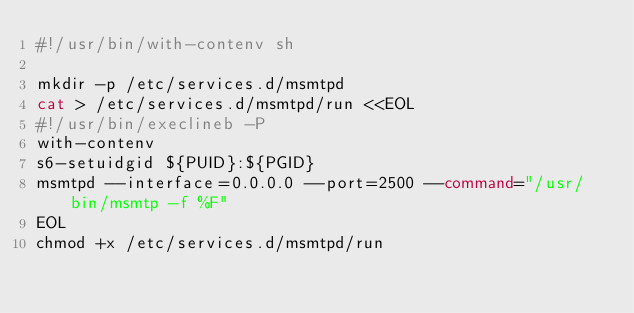Convert code to text. <code><loc_0><loc_0><loc_500><loc_500><_Bash_>#!/usr/bin/with-contenv sh

mkdir -p /etc/services.d/msmtpd
cat > /etc/services.d/msmtpd/run <<EOL
#!/usr/bin/execlineb -P
with-contenv
s6-setuidgid ${PUID}:${PGID}
msmtpd --interface=0.0.0.0 --port=2500 --command="/usr/bin/msmtp -f %F"
EOL
chmod +x /etc/services.d/msmtpd/run
</code> 